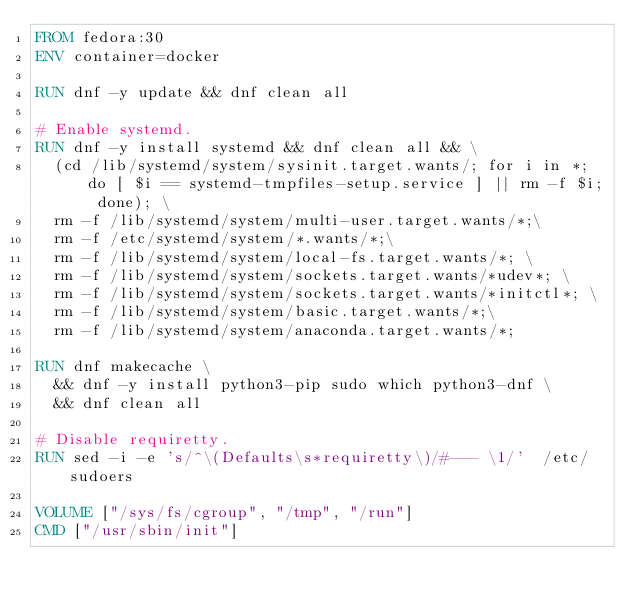Convert code to text. <code><loc_0><loc_0><loc_500><loc_500><_Dockerfile_>FROM fedora:30
ENV container=docker

RUN dnf -y update && dnf clean all

# Enable systemd.
RUN dnf -y install systemd && dnf clean all && \
  (cd /lib/systemd/system/sysinit.target.wants/; for i in *; do [ $i == systemd-tmpfiles-setup.service ] || rm -f $i; done); \
  rm -f /lib/systemd/system/multi-user.target.wants/*;\
  rm -f /etc/systemd/system/*.wants/*;\
  rm -f /lib/systemd/system/local-fs.target.wants/*; \
  rm -f /lib/systemd/system/sockets.target.wants/*udev*; \
  rm -f /lib/systemd/system/sockets.target.wants/*initctl*; \
  rm -f /lib/systemd/system/basic.target.wants/*;\
  rm -f /lib/systemd/system/anaconda.target.wants/*;

RUN dnf makecache \
  && dnf -y install python3-pip sudo which python3-dnf \
  && dnf clean all

# Disable requiretty.
RUN sed -i -e 's/^\(Defaults\s*requiretty\)/#--- \1/'  /etc/sudoers

VOLUME ["/sys/fs/cgroup", "/tmp", "/run"]
CMD ["/usr/sbin/init"]
</code> 